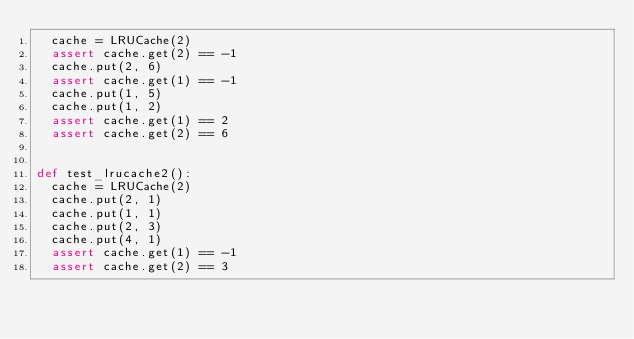Convert code to text. <code><loc_0><loc_0><loc_500><loc_500><_Python_>  cache = LRUCache(2)
  assert cache.get(2) == -1
  cache.put(2, 6)
  assert cache.get(1) == -1
  cache.put(1, 5)
  cache.put(1, 2)
  assert cache.get(1) == 2
  assert cache.get(2) == 6


def test_lrucache2():
  cache = LRUCache(2)
  cache.put(2, 1)
  cache.put(1, 1)
  cache.put(2, 3)
  cache.put(4, 1)
  assert cache.get(1) == -1
  assert cache.get(2) == 3
</code> 